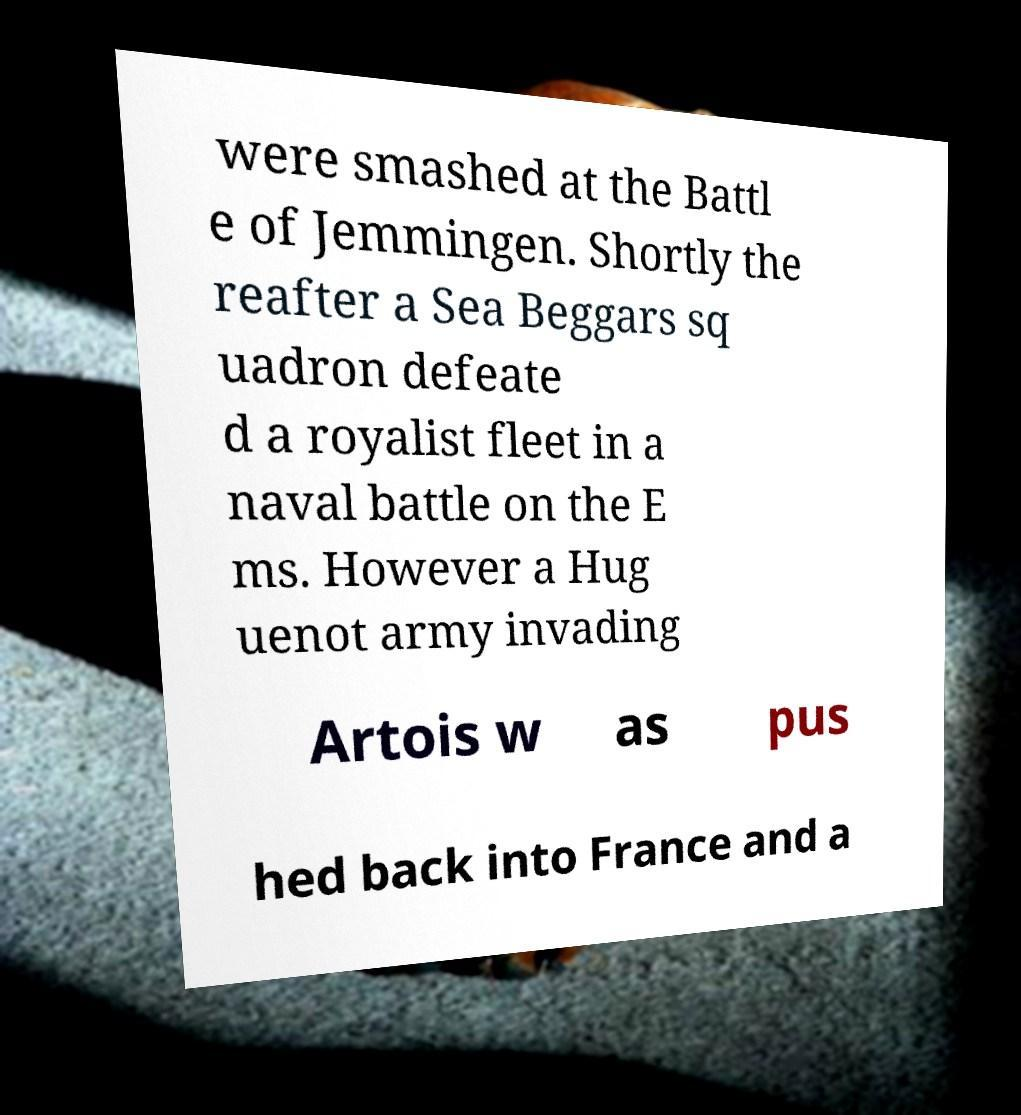Can you read and provide the text displayed in the image?This photo seems to have some interesting text. Can you extract and type it out for me? were smashed at the Battl e of Jemmingen. Shortly the reafter a Sea Beggars sq uadron defeate d a royalist fleet in a naval battle on the E ms. However a Hug uenot army invading Artois w as pus hed back into France and a 